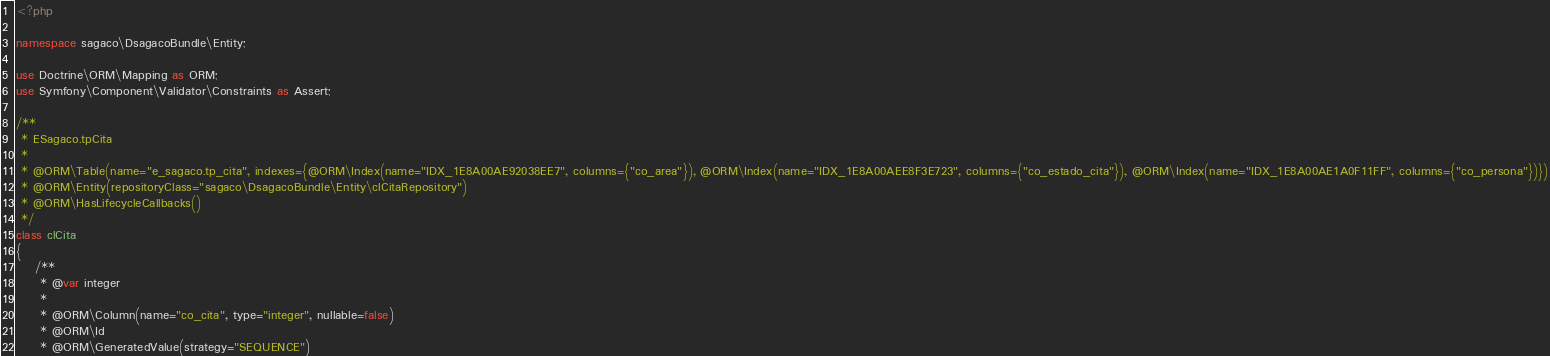<code> <loc_0><loc_0><loc_500><loc_500><_PHP_><?php

namespace sagaco\DsagacoBundle\Entity;

use Doctrine\ORM\Mapping as ORM;
use Symfony\Component\Validator\Constraints as Assert;

/**
 * ESagaco.tpCita
 *
 * @ORM\Table(name="e_sagaco.tp_cita", indexes={@ORM\Index(name="IDX_1E8A00AE92038EE7", columns={"co_area"}), @ORM\Index(name="IDX_1E8A00AEE8F3E723", columns={"co_estado_cita"}), @ORM\Index(name="IDX_1E8A00AE1A0F11FF", columns={"co_persona"})})
 * @ORM\Entity(repositoryClass="sagaco\DsagacoBundle\Entity\clCitaRepository")
 * @ORM\HasLifecycleCallbacks()
 */
class clCita
{
    /**
     * @var integer
     *
     * @ORM\Column(name="co_cita", type="integer", nullable=false)
     * @ORM\Id
     * @ORM\GeneratedValue(strategy="SEQUENCE")</code> 